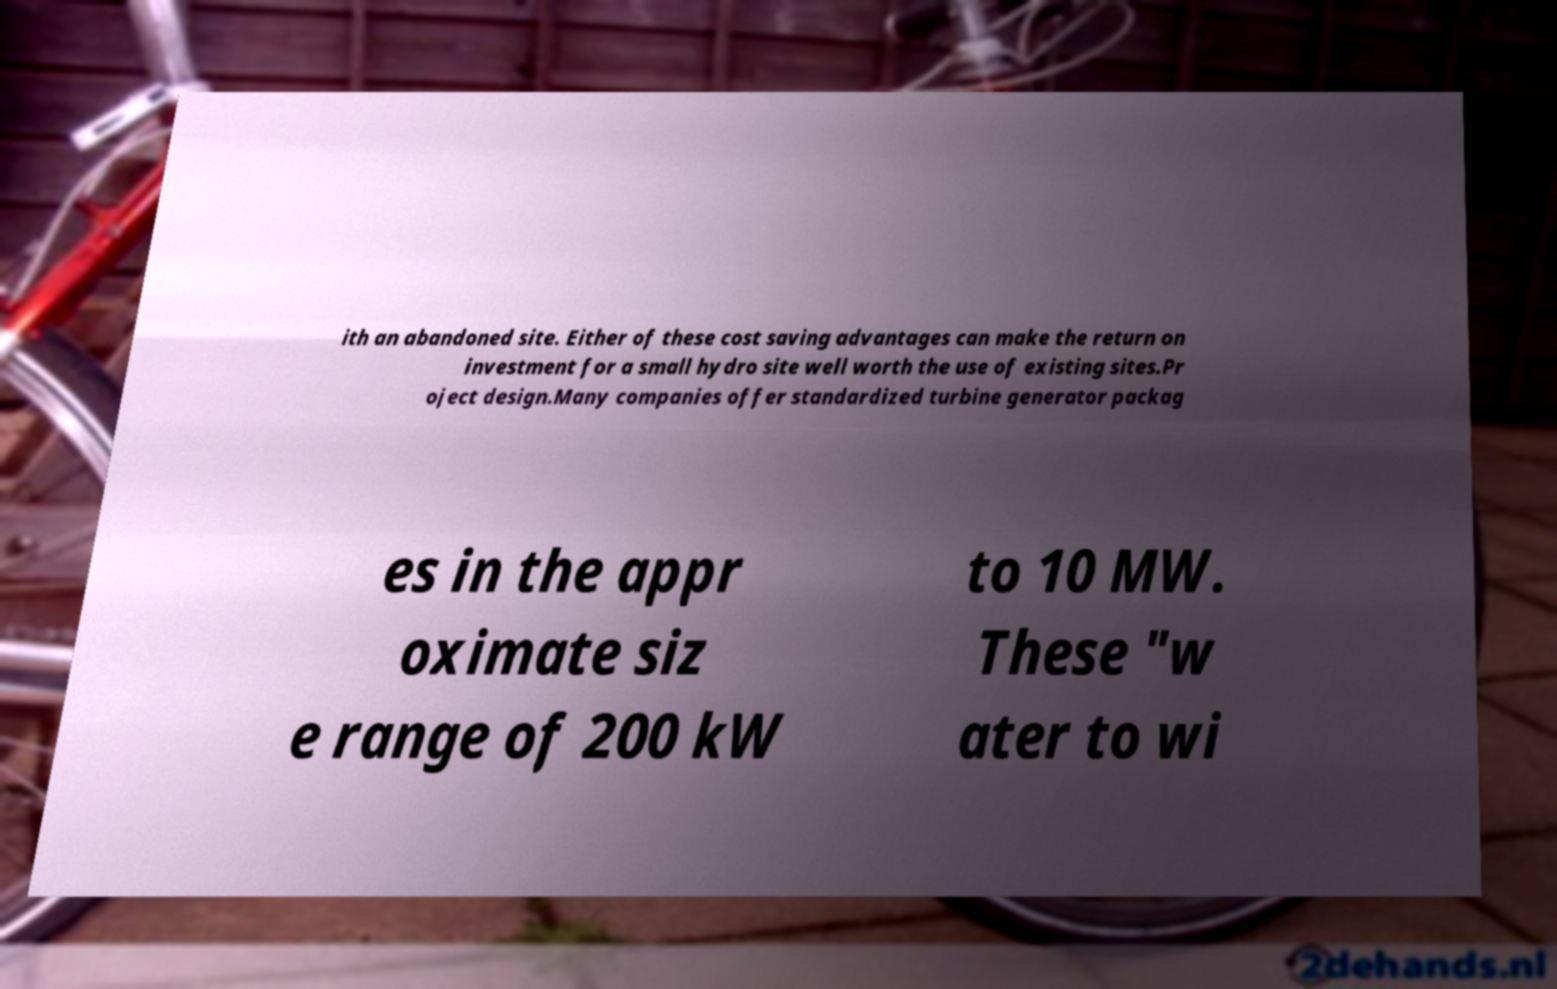Could you assist in decoding the text presented in this image and type it out clearly? ith an abandoned site. Either of these cost saving advantages can make the return on investment for a small hydro site well worth the use of existing sites.Pr oject design.Many companies offer standardized turbine generator packag es in the appr oximate siz e range of 200 kW to 10 MW. These "w ater to wi 